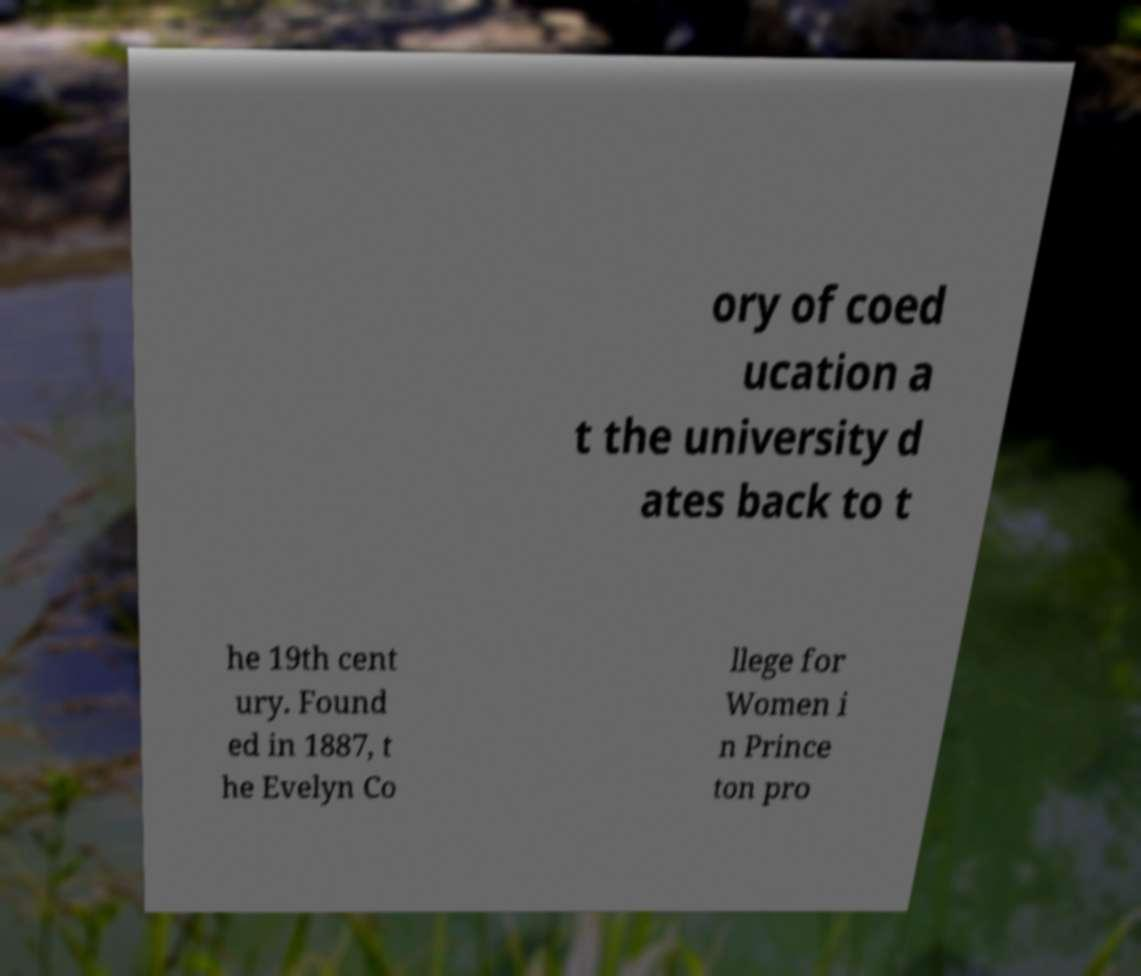Could you extract and type out the text from this image? ory of coed ucation a t the university d ates back to t he 19th cent ury. Found ed in 1887, t he Evelyn Co llege for Women i n Prince ton pro 